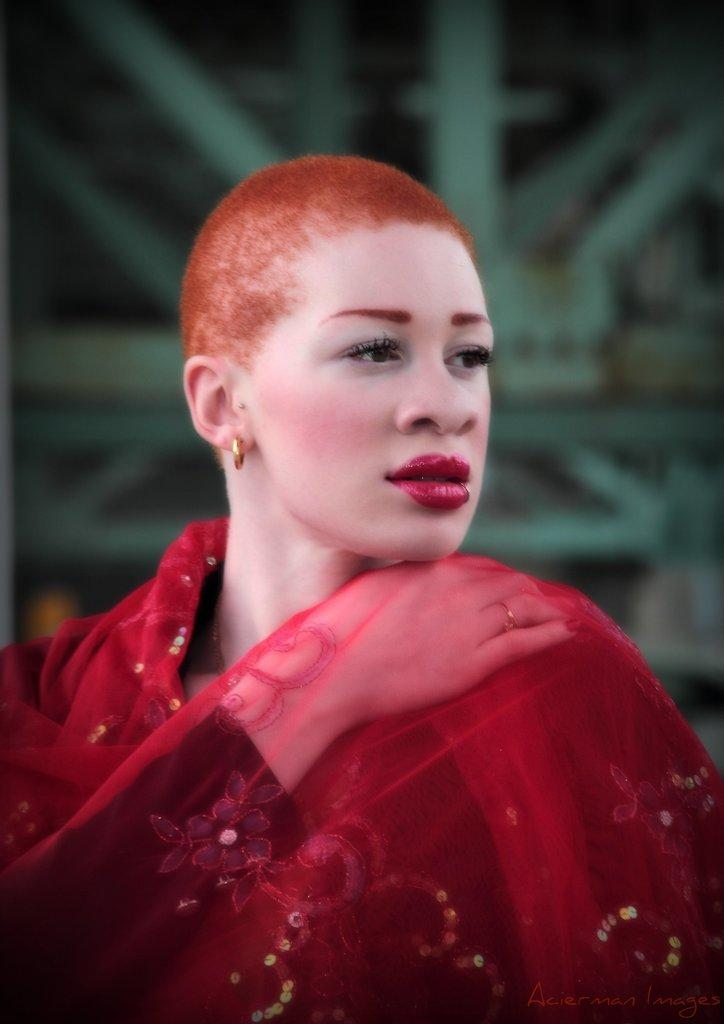What is the main subject of the image? There is a person in the image. What is the person wearing? The person is wearing a red dress. Can you describe the background of the image? The background of the image is blurred. What type of ball is being used by the person in the image? There is no ball present in the image. Is the person in the image using any form of transport? There is no indication of any form of transport in the image. 